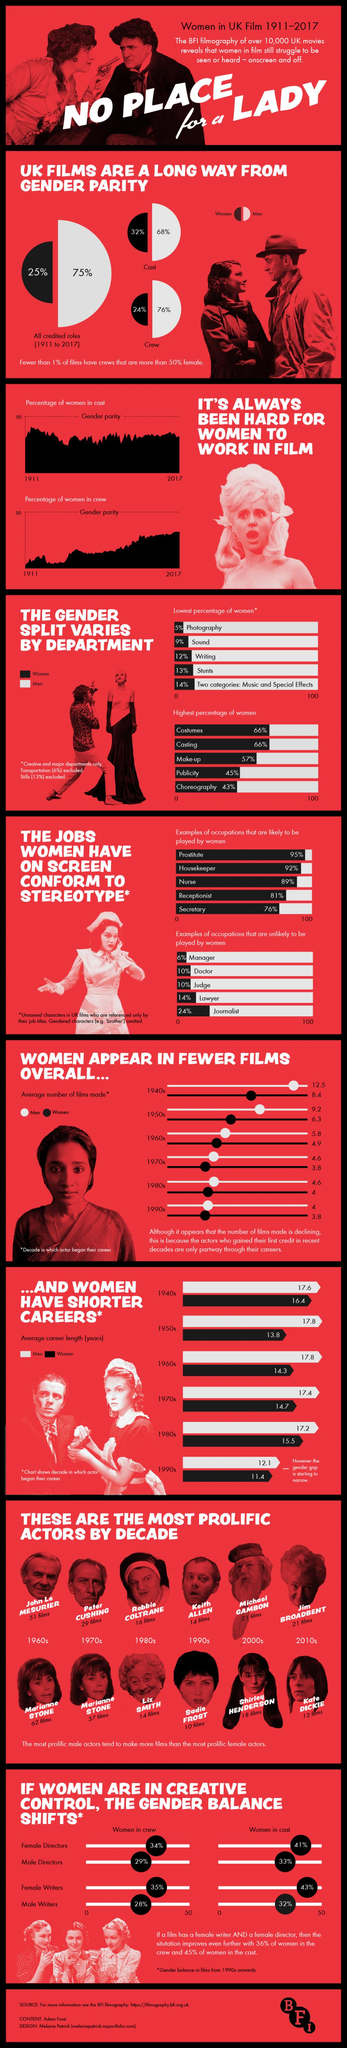Specify some key components in this picture. During the period of 1911 to 2017, the Department of Photography in the United Kingdom supported the least female population out of all the departments. In the 1980s, the average career length of women in UK films was 15.5 years. During the period of 1911 to 2017 in UK films, the role of manager was least performed by women. In the UK, it is reported that only 24% of film crew members are female. During the period of 1911-2017, 88% of UK film writers were men. 